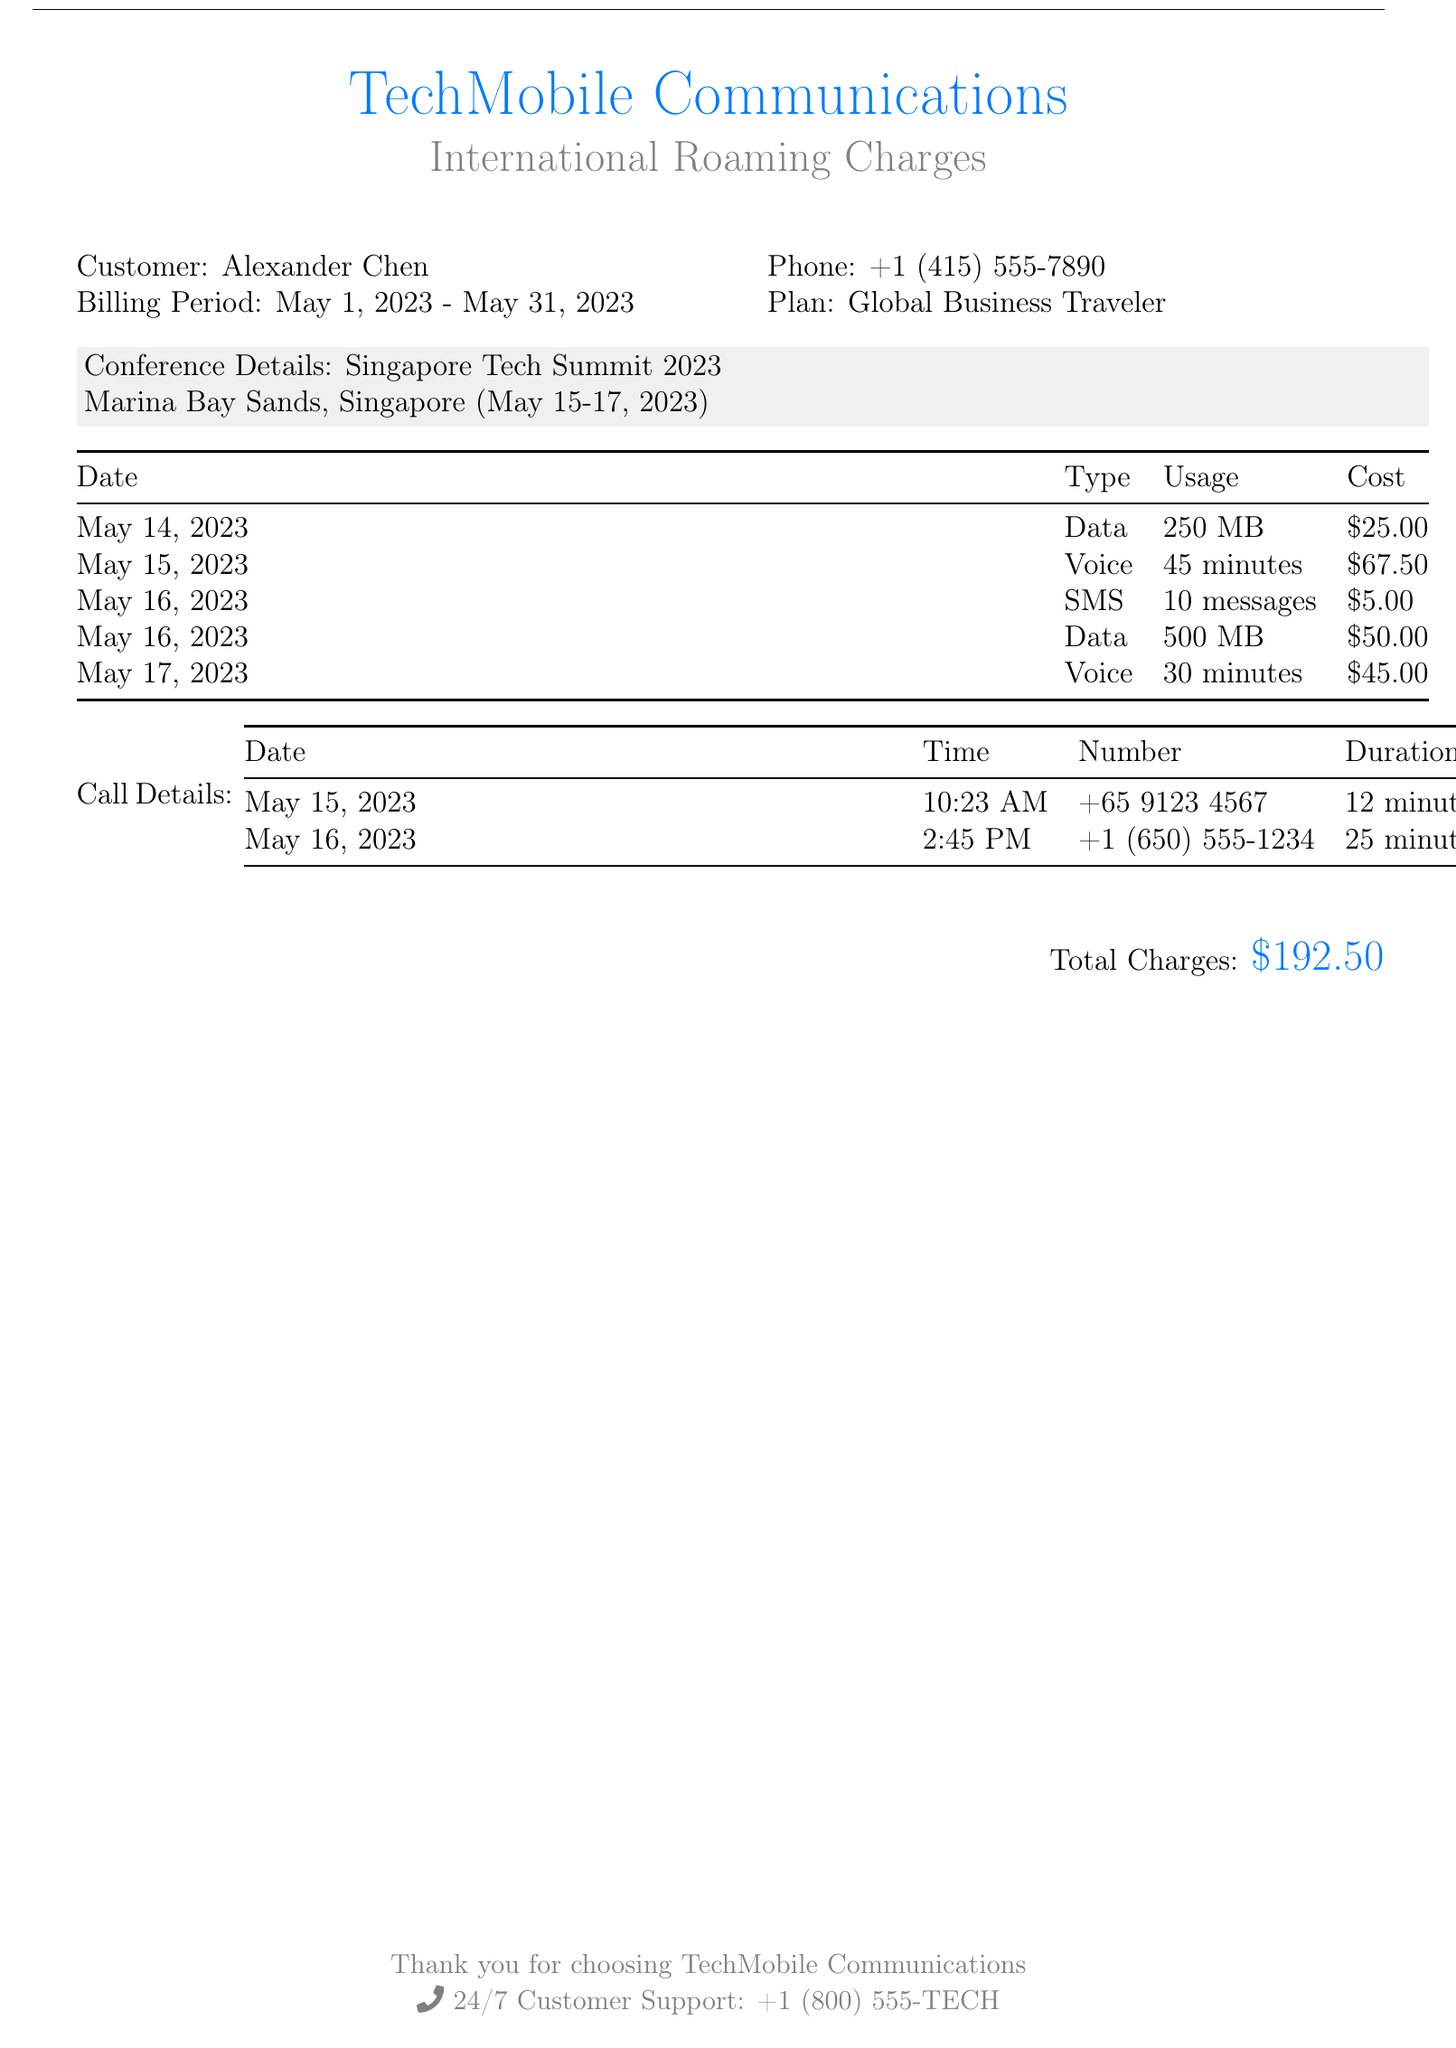What is the name of the customer? The document specifies that the customer is Alexander Chen.
Answer: Alexander Chen What is the phone number on the bill? The document provides the phone number as +1 (415) 555-7890.
Answer: +1 (415) 555-7890 What is the billing period? The billing period mentioned in the document is from May 1, 2023, to May 31, 2023.
Answer: May 1, 2023 - May 31, 2023 How much did the voice usage cost on May 15, 2023? The document indicates that the voice usage on this date cost $67.50.
Answer: $67.50 What date was the conference held? The conference was held from May 15 to May 17, 2023.
Answer: May 15-17, 2023 How much data was used on May 16, 2023? According to the document, 500 MB of data was used on this date.
Answer: 500 MB What was the total charge for the document? The total charges calculated in the document amount to $192.50.
Answer: $192.50 How many minutes of voice calls were made during the trip? The document lists two voice calls, one for 45 minutes and another for 30 minutes, totaling 75 minutes.
Answer: 75 minutes How many messages were sent on May 16, 2023? The document states that 10 messages were sent on May 16, 2023.
Answer: 10 messages 